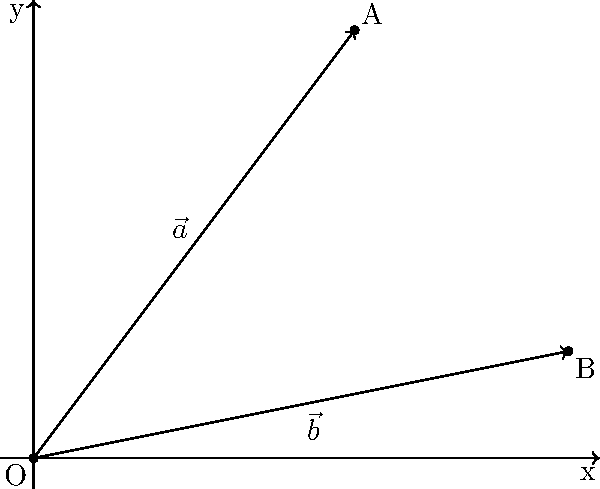As a software engineer preparing for a presentation, you need to calculate the angle between two vectors for a data visualization project. Given vectors $\vec{a}$ and $\vec{b}$ in the coordinate plane as shown, determine the angle $\theta$ between them. Round your answer to the nearest degree. To find the angle between two vectors, we can use the dot product formula:

$$\cos \theta = \frac{\vec{a} \cdot \vec{b}}{|\vec{a}| |\vec{b}|}$$

Step 1: Identify the components of the vectors
$\vec{a} = (3, 4)$
$\vec{b} = (5, 1)$

Step 2: Calculate the dot product $\vec{a} \cdot \vec{b}$
$\vec{a} \cdot \vec{b} = (3 \times 5) + (4 \times 1) = 15 + 4 = 19$

Step 3: Calculate the magnitudes of the vectors
$|\vec{a}| = \sqrt{3^2 + 4^2} = \sqrt{9 + 16} = \sqrt{25} = 5$
$|\vec{b}| = \sqrt{5^2 + 1^2} = \sqrt{25 + 1} = \sqrt{26}$

Step 4: Apply the dot product formula
$$\cos \theta = \frac{19}{5\sqrt{26}}$$

Step 5: Take the inverse cosine (arccos) of both sides
$$\theta = \arccos\left(\frac{19}{5\sqrt{26}}\right)$$

Step 6: Calculate and round to the nearest degree
$\theta \approx 44.42°$, which rounds to 44°
Answer: 44° 